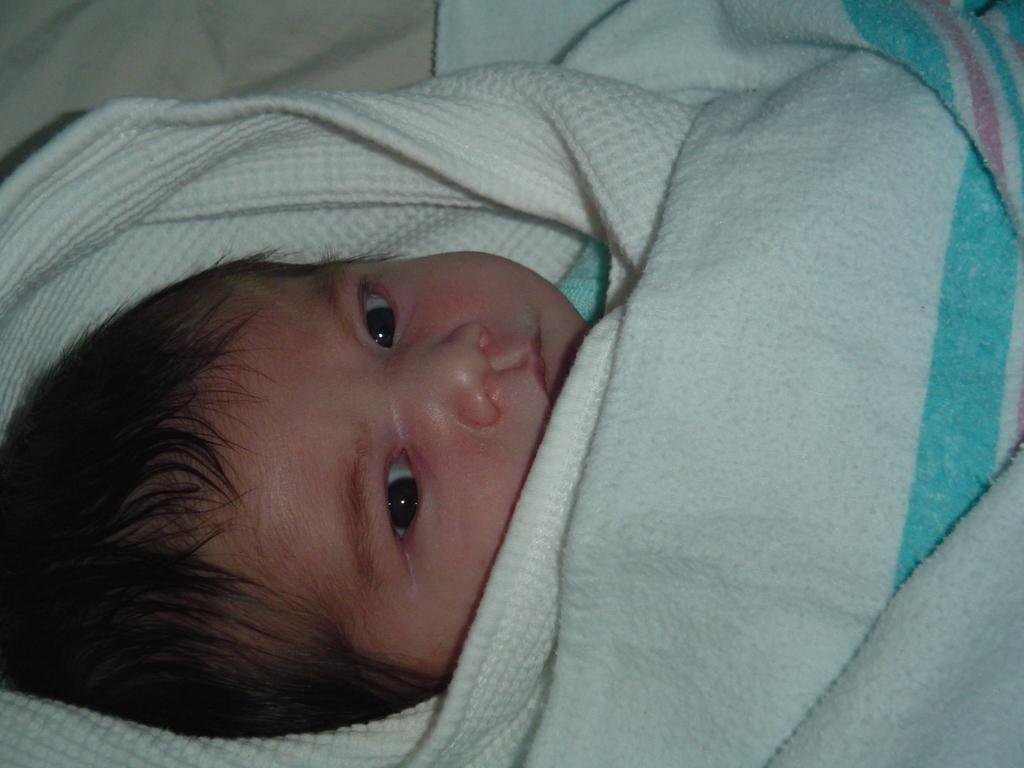What is the main subject of the image? There is a child in the image. How is the child dressed or covered in the image? The child is wrapped in a blanket. What type of pan is being used to lift the child in the image? There is no pan or lifting action present in the image; the child is simply wrapped in a blanket. What is the child holding in their hand that is quivering in the image? There is no object being held or quivering in the child's hand in the image. 